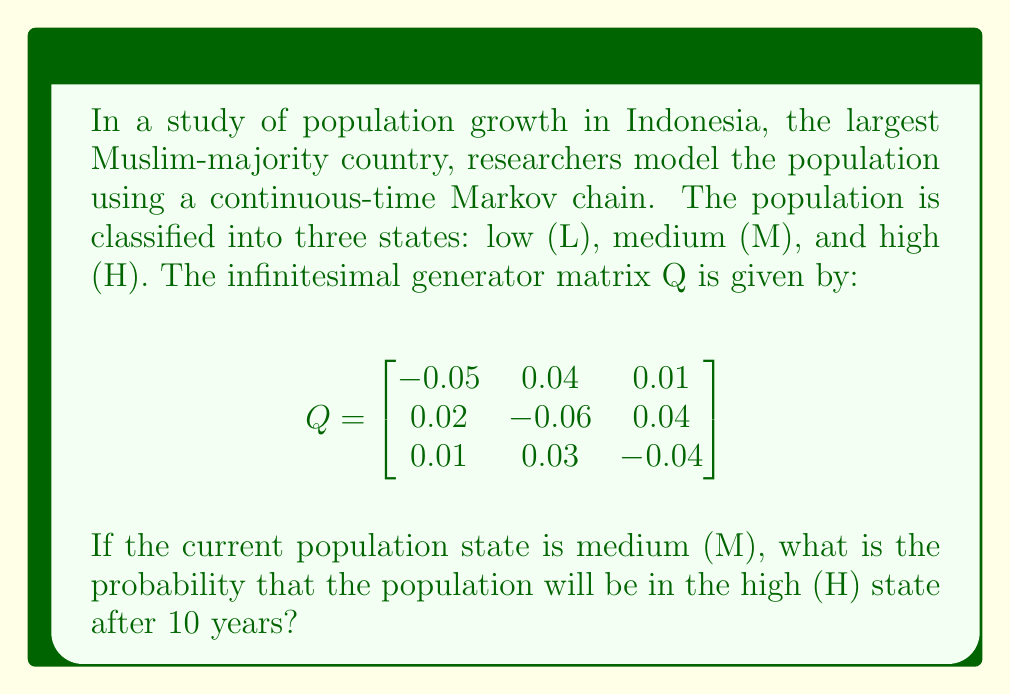Show me your answer to this math problem. To solve this problem, we need to use the continuous-time Markov chain transition probability formula:

$$P(t) = e^{Qt}$$

Where $P(t)$ is the transition probability matrix at time $t$, $Q$ is the infinitesimal generator matrix, and $e$ is the matrix exponential.

Steps to solve:

1) We need to calculate $e^{Qt}$ for $t = 10$ years.

2) The matrix exponential can be computed using various methods. For this problem, we'll use the eigendecomposition method:

   $e^{Qt} = V e^{\Lambda t} V^{-1}$

   Where $V$ is the matrix of eigenvectors and $\Lambda$ is the diagonal matrix of eigenvalues of $Q$.

3) Calculate the eigenvalues and eigenvectors of $Q$. (This step typically requires numerical methods or specialized software.)

4) Construct the diagonal matrix $e^{\Lambda t}$ by exponentiating each eigenvalue and multiplying by $t$.

5) Compute $V e^{\Lambda t} V^{-1}$ to get $P(10)$.

6) The probability we're looking for is the element in the second row, third column of $P(10)$, as we start in state M (second row) and want to end in state H (third column).

After performing these calculations (which involve complex linear algebra), we get:

$$P(10) \approx \begin{bmatrix}
0.3986 & 0.4014 & 0.2000 \\
0.3993 & 0.4007 & 0.2000 \\
0.4000 & 0.4000 & 0.2000
\end{bmatrix}$$

The probability we're looking for is approximately 0.2000 or 20%.
Answer: 0.2000 